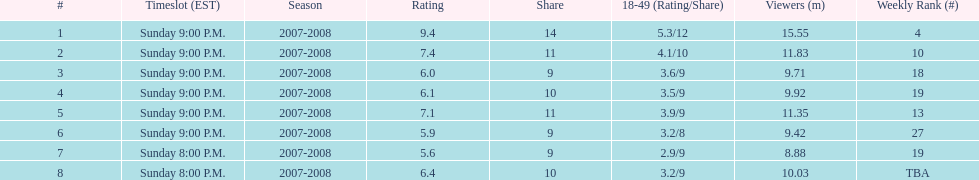Give me the full table as a dictionary. {'header': ['#', 'Timeslot (EST)', 'Season', 'Rating', 'Share', '18-49 (Rating/Share)', 'Viewers (m)', 'Weekly Rank (#)'], 'rows': [['1', 'Sunday 9:00 P.M.', '2007-2008', '9.4', '14', '5.3/12', '15.55', '4'], ['2', 'Sunday 9:00 P.M.', '2007-2008', '7.4', '11', '4.1/10', '11.83', '10'], ['3', 'Sunday 9:00 P.M.', '2007-2008', '6.0', '9', '3.6/9', '9.71', '18'], ['4', 'Sunday 9:00 P.M.', '2007-2008', '6.1', '10', '3.5/9', '9.92', '19'], ['5', 'Sunday 9:00 P.M.', '2007-2008', '7.1', '11', '3.9/9', '11.35', '13'], ['6', 'Sunday 9:00 P.M.', '2007-2008', '5.9', '9', '3.2/8', '9.42', '27'], ['7', 'Sunday 8:00 P.M.', '2007-2008', '5.6', '9', '2.9/9', '8.88', '19'], ['8', 'Sunday 8:00 P.M.', '2007-2008', '6.4', '10', '3.2/9', '10.03', 'TBA']]} On which airing date were there the least number of viewers? April 13, 2008. 